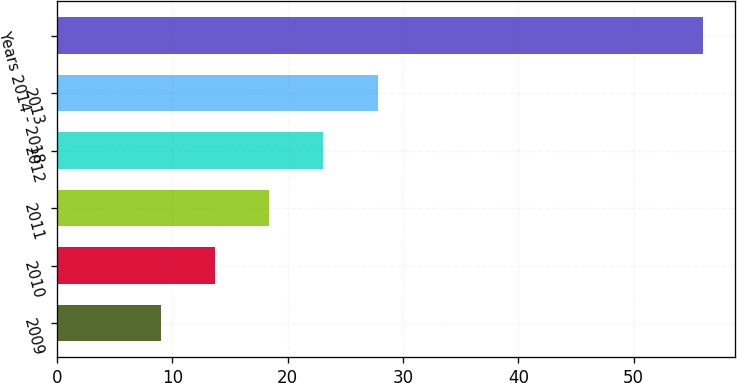<chart> <loc_0><loc_0><loc_500><loc_500><bar_chart><fcel>2009<fcel>2010<fcel>2011<fcel>2012<fcel>2013<fcel>Years 2014 - 2018<nl><fcel>9<fcel>13.7<fcel>18.4<fcel>23.1<fcel>27.8<fcel>56<nl></chart> 